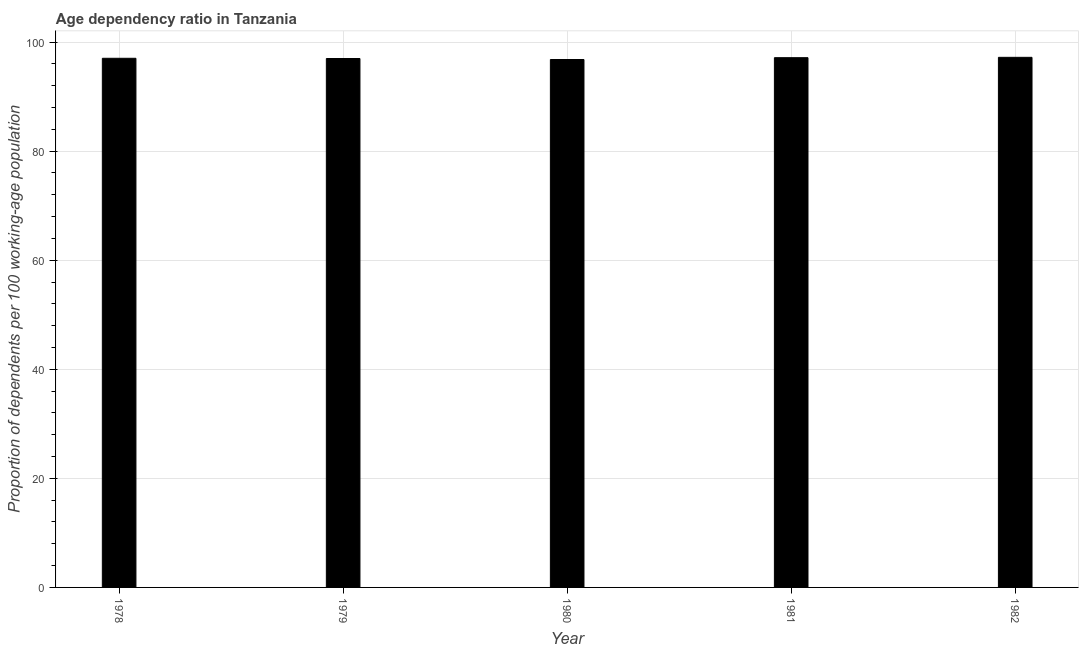Does the graph contain grids?
Keep it short and to the point. Yes. What is the title of the graph?
Your response must be concise. Age dependency ratio in Tanzania. What is the label or title of the Y-axis?
Your response must be concise. Proportion of dependents per 100 working-age population. What is the age dependency ratio in 1982?
Keep it short and to the point. 97.2. Across all years, what is the maximum age dependency ratio?
Ensure brevity in your answer.  97.2. Across all years, what is the minimum age dependency ratio?
Give a very brief answer. 96.8. In which year was the age dependency ratio maximum?
Provide a short and direct response. 1982. What is the sum of the age dependency ratio?
Offer a terse response. 485.13. What is the difference between the age dependency ratio in 1980 and 1982?
Your answer should be compact. -0.4. What is the average age dependency ratio per year?
Offer a very short reply. 97.03. What is the median age dependency ratio?
Ensure brevity in your answer.  97.02. In how many years, is the age dependency ratio greater than 76 ?
Your answer should be very brief. 5. Do a majority of the years between 1980 and 1978 (inclusive) have age dependency ratio greater than 16 ?
Make the answer very short. Yes. What is the ratio of the age dependency ratio in 1980 to that in 1981?
Your response must be concise. 1. Is the age dependency ratio in 1980 less than that in 1981?
Offer a terse response. Yes. Is the difference between the age dependency ratio in 1978 and 1982 greater than the difference between any two years?
Keep it short and to the point. No. What is the difference between the highest and the second highest age dependency ratio?
Give a very brief answer. 0.07. Is the sum of the age dependency ratio in 1981 and 1982 greater than the maximum age dependency ratio across all years?
Your answer should be compact. Yes. What is the difference between the highest and the lowest age dependency ratio?
Provide a succinct answer. 0.4. In how many years, is the age dependency ratio greater than the average age dependency ratio taken over all years?
Make the answer very short. 2. Are the values on the major ticks of Y-axis written in scientific E-notation?
Ensure brevity in your answer.  No. What is the Proportion of dependents per 100 working-age population in 1978?
Make the answer very short. 97.02. What is the Proportion of dependents per 100 working-age population in 1979?
Your answer should be compact. 96.98. What is the Proportion of dependents per 100 working-age population of 1980?
Your answer should be compact. 96.8. What is the Proportion of dependents per 100 working-age population of 1981?
Your answer should be compact. 97.13. What is the Proportion of dependents per 100 working-age population of 1982?
Provide a succinct answer. 97.2. What is the difference between the Proportion of dependents per 100 working-age population in 1978 and 1979?
Your answer should be very brief. 0.04. What is the difference between the Proportion of dependents per 100 working-age population in 1978 and 1980?
Provide a succinct answer. 0.22. What is the difference between the Proportion of dependents per 100 working-age population in 1978 and 1981?
Your answer should be very brief. -0.11. What is the difference between the Proportion of dependents per 100 working-age population in 1978 and 1982?
Your answer should be very brief. -0.18. What is the difference between the Proportion of dependents per 100 working-age population in 1979 and 1980?
Offer a very short reply. 0.18. What is the difference between the Proportion of dependents per 100 working-age population in 1979 and 1981?
Your response must be concise. -0.15. What is the difference between the Proportion of dependents per 100 working-age population in 1979 and 1982?
Give a very brief answer. -0.22. What is the difference between the Proportion of dependents per 100 working-age population in 1980 and 1981?
Your answer should be compact. -0.33. What is the difference between the Proportion of dependents per 100 working-age population in 1980 and 1982?
Offer a terse response. -0.4. What is the difference between the Proportion of dependents per 100 working-age population in 1981 and 1982?
Keep it short and to the point. -0.07. What is the ratio of the Proportion of dependents per 100 working-age population in 1978 to that in 1979?
Keep it short and to the point. 1. What is the ratio of the Proportion of dependents per 100 working-age population in 1978 to that in 1981?
Provide a short and direct response. 1. What is the ratio of the Proportion of dependents per 100 working-age population in 1979 to that in 1980?
Offer a terse response. 1. What is the ratio of the Proportion of dependents per 100 working-age population in 1979 to that in 1981?
Provide a short and direct response. 1. What is the ratio of the Proportion of dependents per 100 working-age population in 1980 to that in 1982?
Ensure brevity in your answer.  1. 